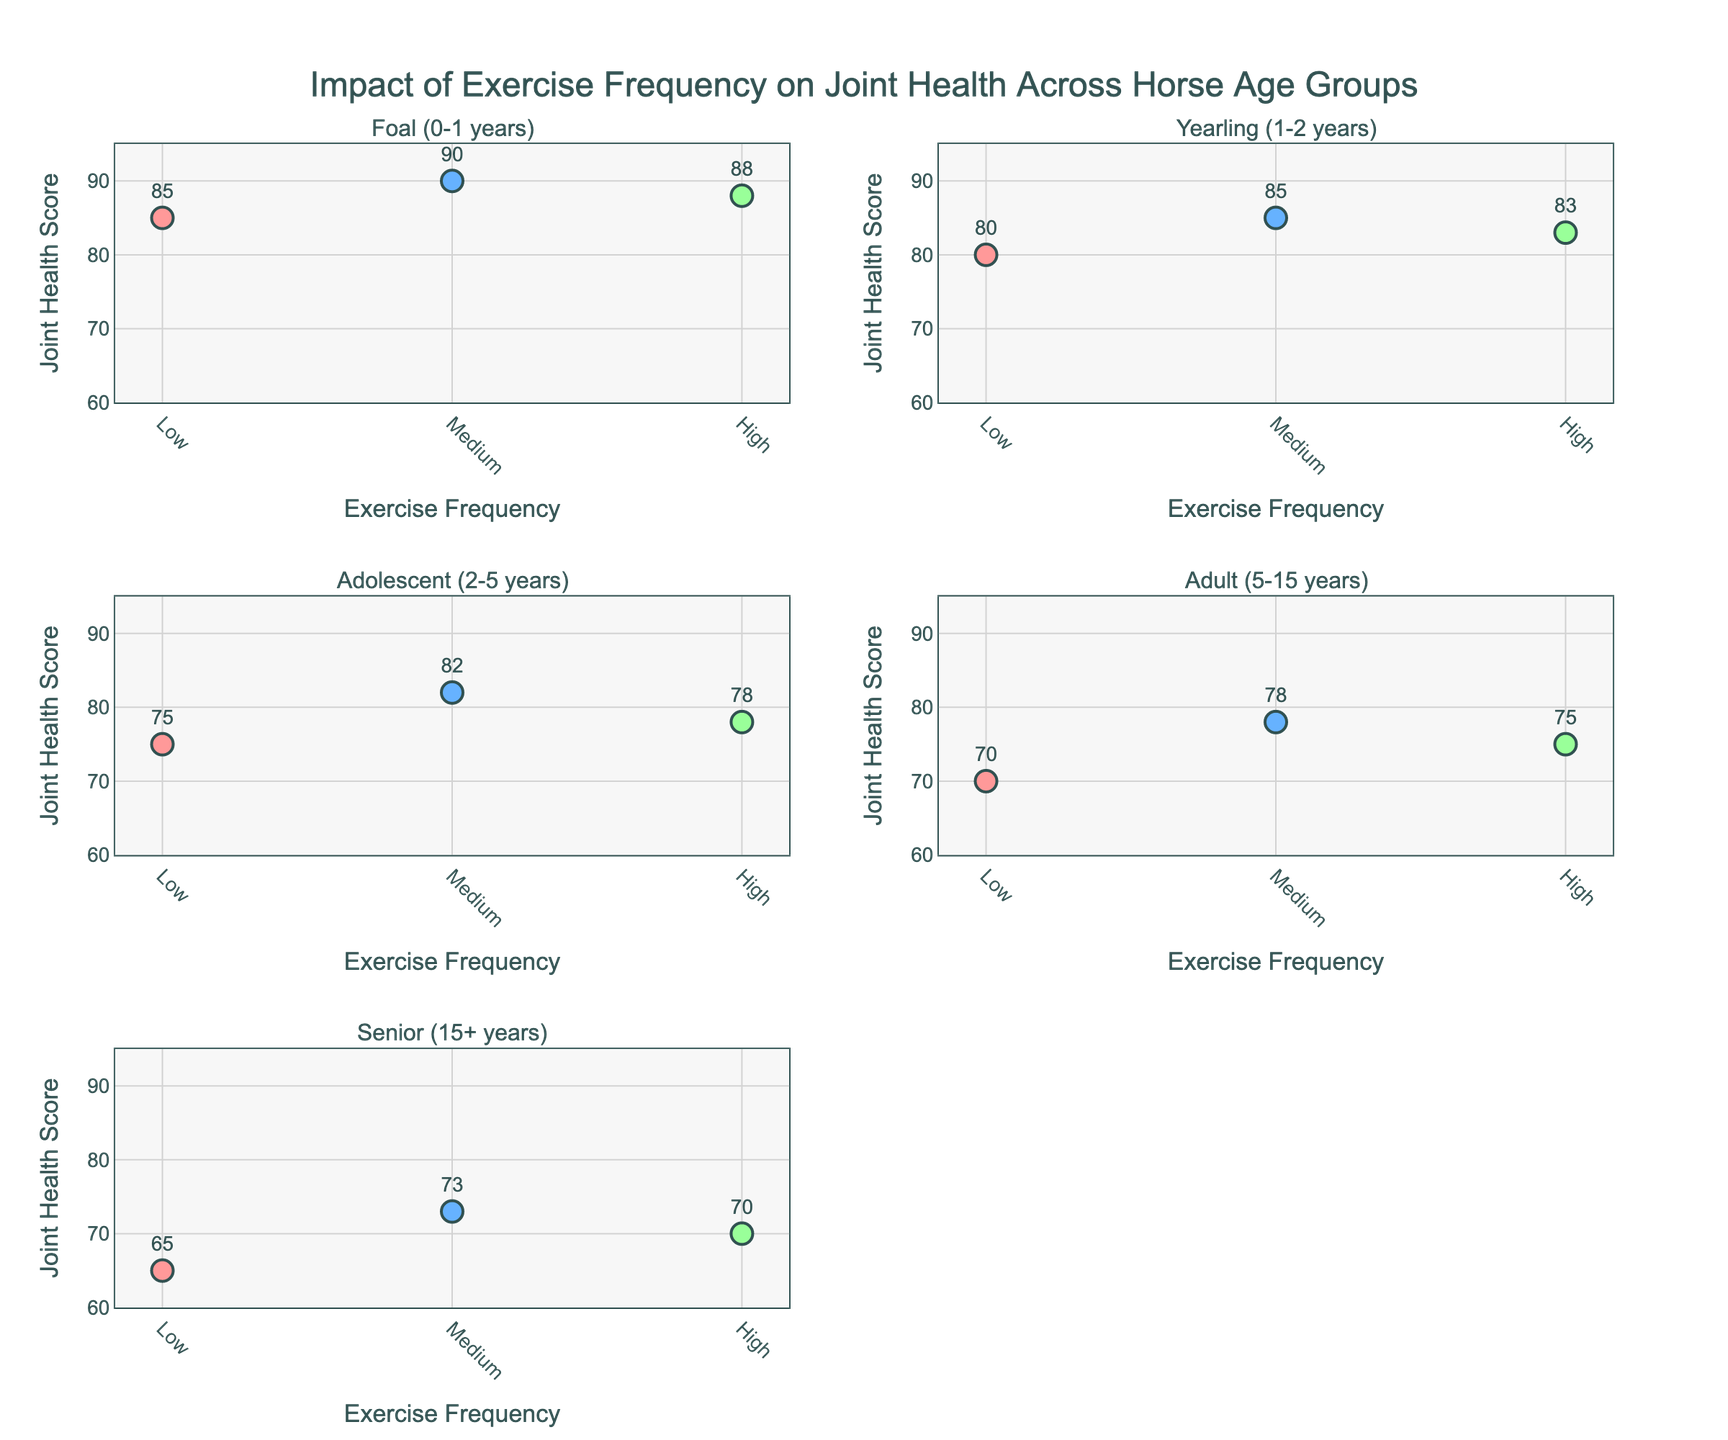What is the color used for 'Medium' exercise frequency? By looking at the scatter plot, the 'Medium' exercise frequency data points are shown in blue color.
Answer: Blue Which age group shows the highest average Joint Health Score at 'Medium' exercise frequency? To determine this, find the average Joint Health Score for each age group at 'Medium' exercise frequency and compare them. The average scores are as follows: Foal: 90, Yearling: 85, Adolescent: 82, Adult: 78, Senior: 73. The highest average is in the Foal age group.
Answer: Foal In the 'Senior (15+ years)' age group, how does the Joint Health Score vary with exercise frequency? In the 'Senior' age group, the Joint Health Scores for Low, Medium, and High exercise frequencies are 65, 73, and 70 respectively. Thus, the score increases from Low to Medium, then slightly decreases to High.
Answer: Increases then decreases What difference can you observe in Joint Health Scores between 'Low' and 'High' exercise frequency for the 'Adult (5-15 years)' age group? For the 'Adult' age group, compare the Joint Health Scores for Low (70) and High (75) exercise frequencies. The score is 5 points higher for 'High' frequency compared to 'Low'.
Answer: 5 points higher Which age group has the least Joint Health Score variation across different exercise frequencies? To find this, calculate the range of Joint Health Scores for each age group: Foal: 5 (90-85), Yearling: 5 (85-80), Adolescent: 7 (82-75), Adult: 8 (78-70), Senior: 8 (73-65). The Foal and Yearling groups both have the least variation of 5 points.
Answer: Foal and Yearling Among all age groups and exercise frequencies, which data point has the highest Joint Health Score? By examining the scatter plots, the 'Medium' exercise frequency for the 'Foal (0-1 years)' age group has the highest Joint Health Score of 90.
Answer: Foal (0-1 years) - Medium How does Joint Health Score differ between 'Low' and 'Medium' exercise frequencies within the 'Adolescent (2-5 years)' age group? For the Adolescent age group, look at the Joint Health Scores for 'Low' (75) and 'Medium' (82) exercise frequencies. The score increases by 7 points from Low to Medium.
Answer: Increases by 7 points What are the Joint Health Scores for 'High' exercise frequency in the 'Yearling (1-2 years)' age group? Looking at the scatter plot, the Joint Health Score for 'High' exercise frequency in the 'Yearling' age group is 83.
Answer: 83 